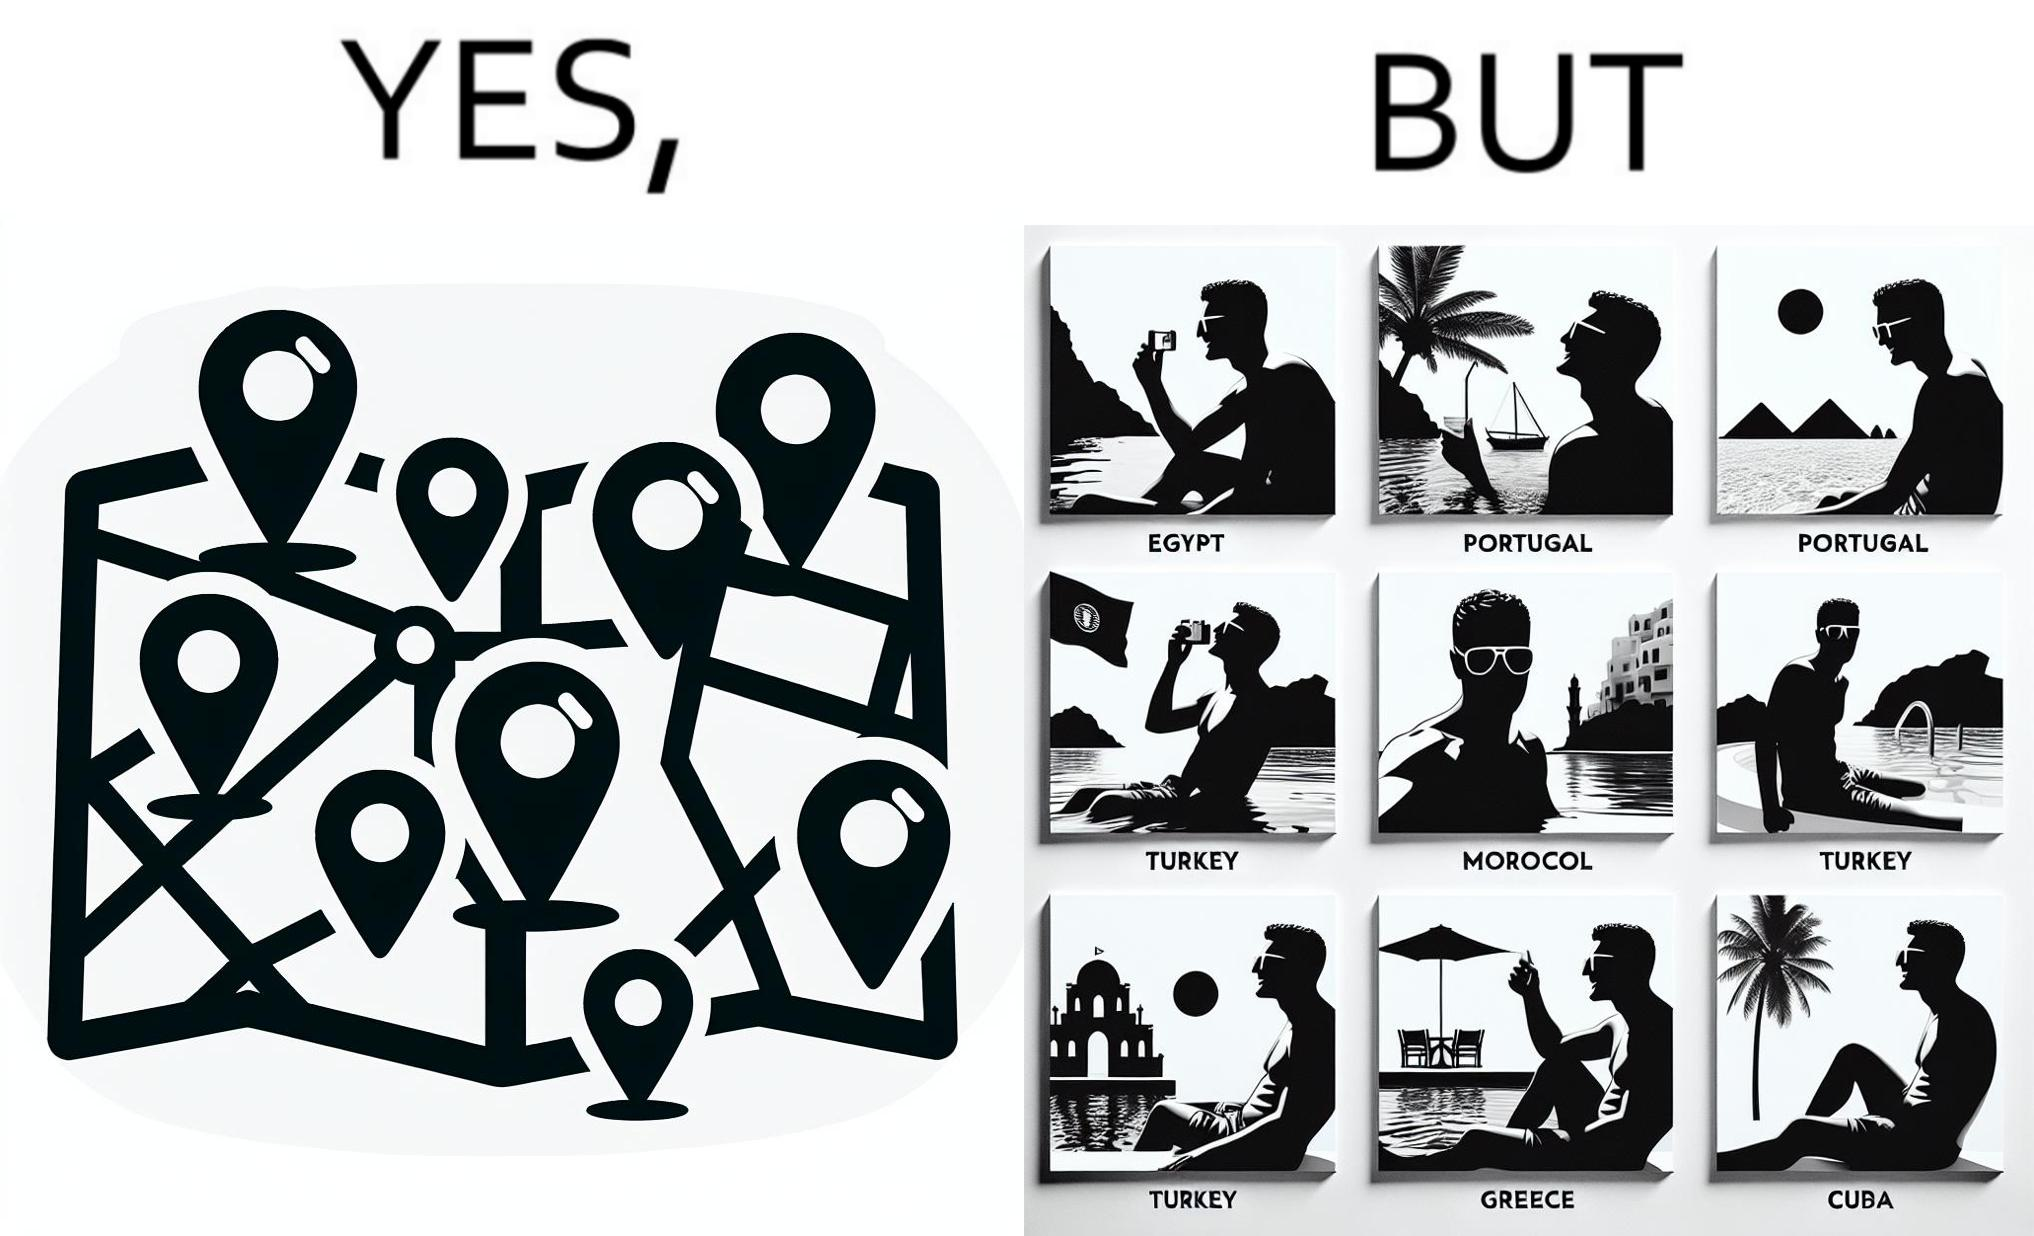What is shown in this image? The image is satirical because while the man has visited all the place marked on the map, he only seems to have swam in pools in all these differnt countries and has not actually seen these places. 